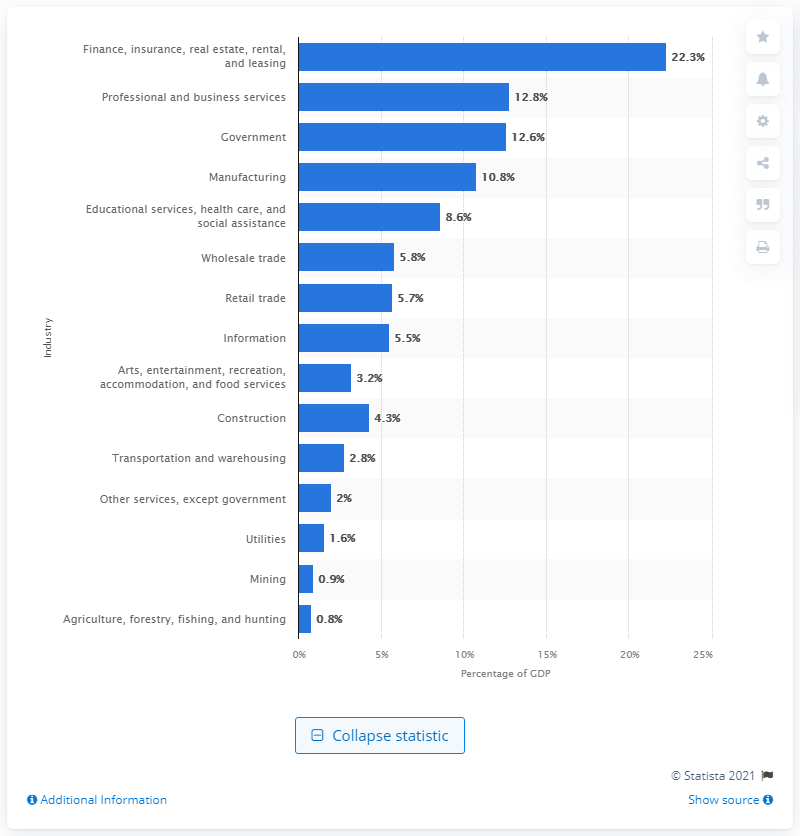Identify some key points in this picture. In 2020, the mining industry contributed 0.9% of the total value added to the U.S. Gross Domestic Product. 